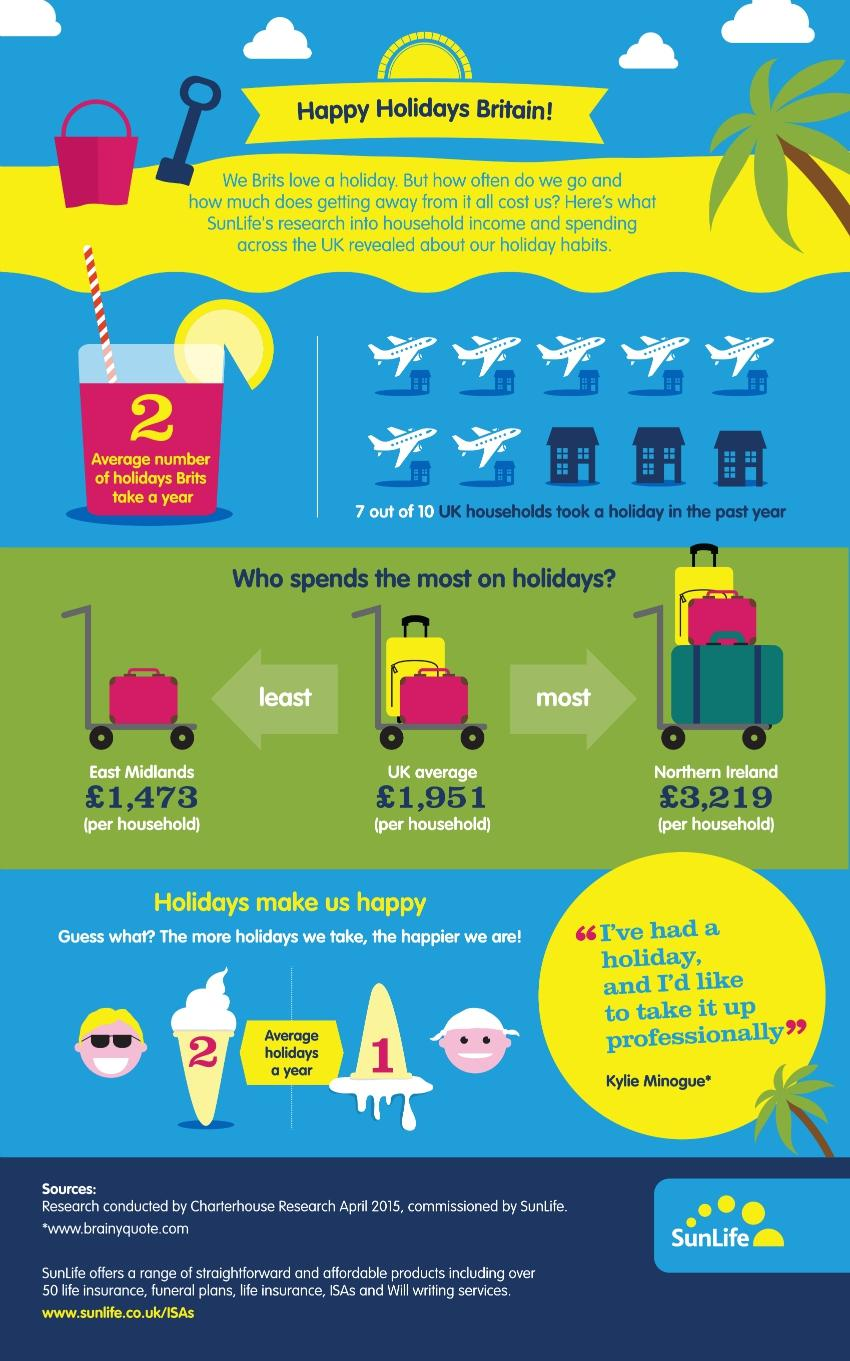Identify some key points in this picture. On average, households in the UK spend approximately £1,951 per year on holidays. According to a recent survey, Northern Ireland is the country in the United Kingdom that spends the most money on holidays. In Northern Ireland, the average household spends approximately £3,219 on holidays each year. 